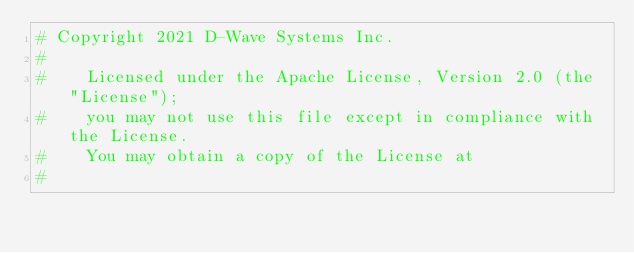Convert code to text. <code><loc_0><loc_0><loc_500><loc_500><_Cython_># Copyright 2021 D-Wave Systems Inc.
#
#    Licensed under the Apache License, Version 2.0 (the "License");
#    you may not use this file except in compliance with the License.
#    You may obtain a copy of the License at
#</code> 